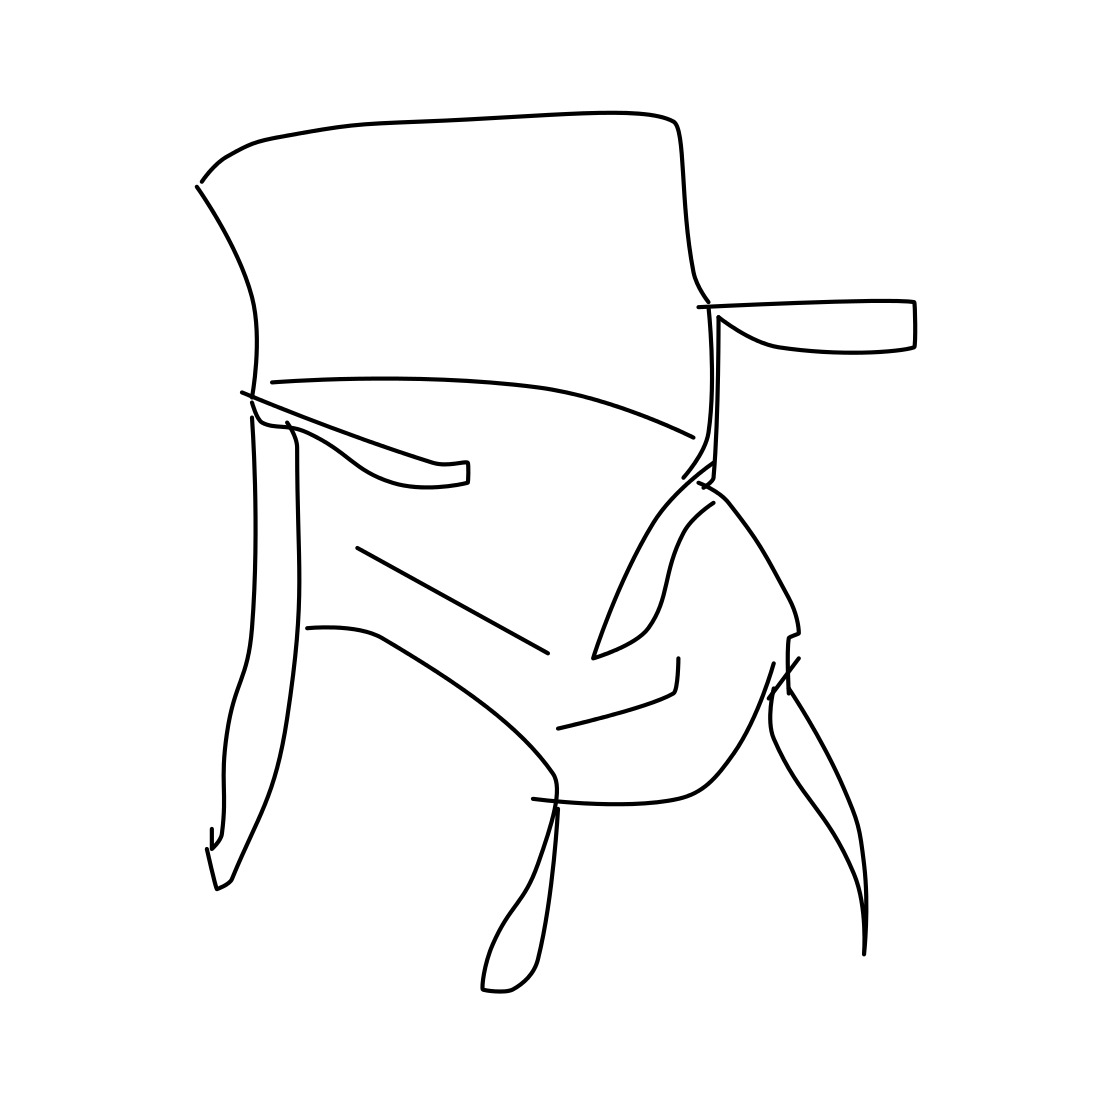In the scene, is a tree in it? No 